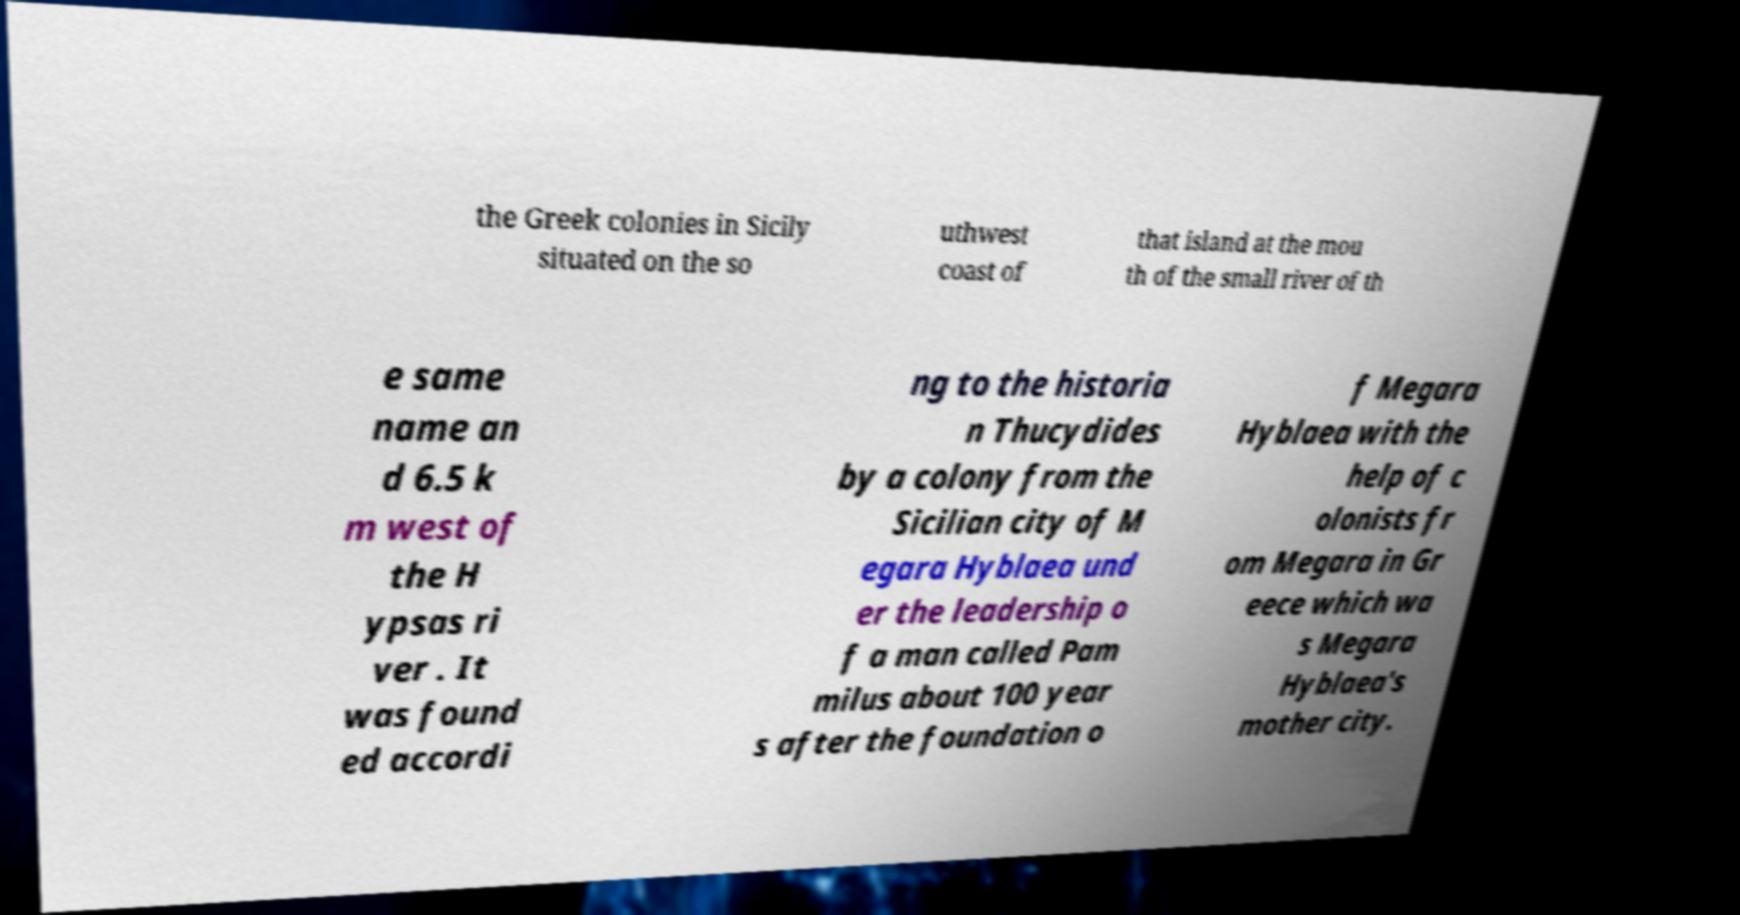Please read and relay the text visible in this image. What does it say? the Greek colonies in Sicily situated on the so uthwest coast of that island at the mou th of the small river of th e same name an d 6.5 k m west of the H ypsas ri ver . It was found ed accordi ng to the historia n Thucydides by a colony from the Sicilian city of M egara Hyblaea und er the leadership o f a man called Pam milus about 100 year s after the foundation o f Megara Hyblaea with the help of c olonists fr om Megara in Gr eece which wa s Megara Hyblaea's mother city. 